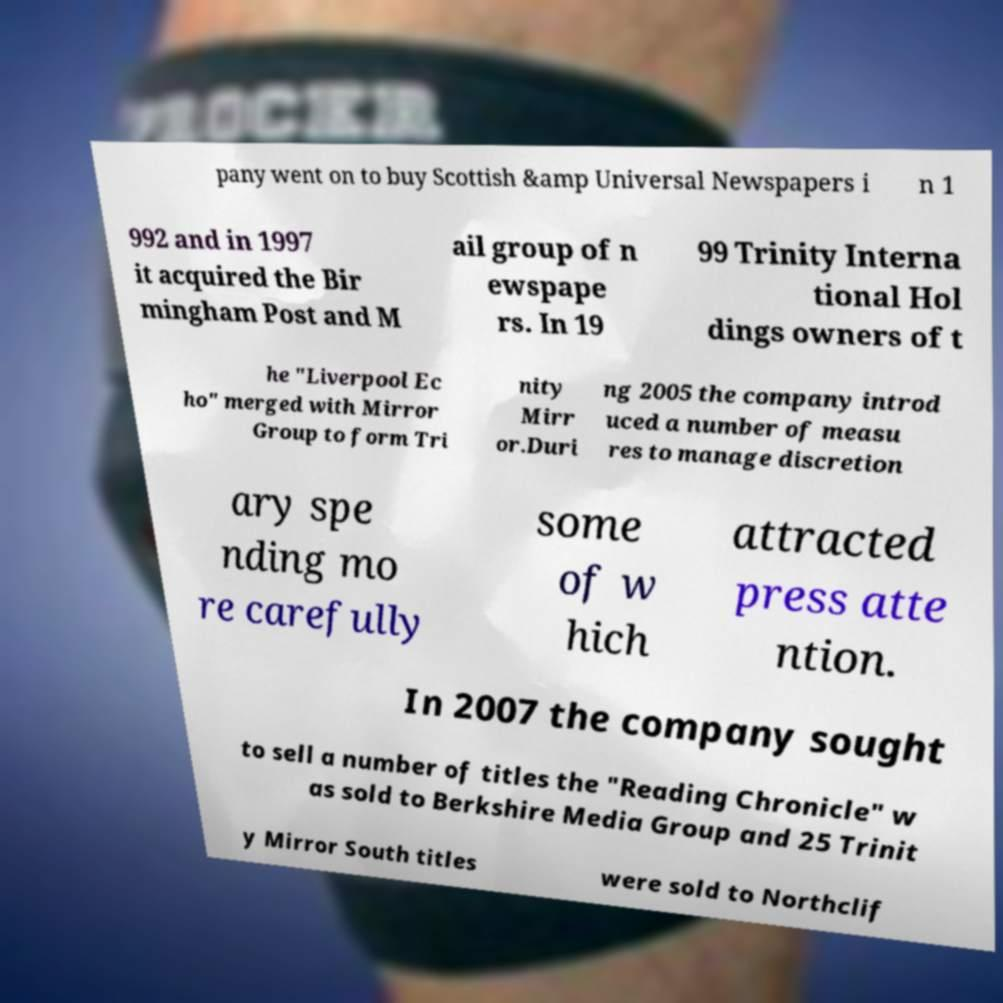For documentation purposes, I need the text within this image transcribed. Could you provide that? pany went on to buy Scottish &amp Universal Newspapers i n 1 992 and in 1997 it acquired the Bir mingham Post and M ail group of n ewspape rs. In 19 99 Trinity Interna tional Hol dings owners of t he "Liverpool Ec ho" merged with Mirror Group to form Tri nity Mirr or.Duri ng 2005 the company introd uced a number of measu res to manage discretion ary spe nding mo re carefully some of w hich attracted press atte ntion. In 2007 the company sought to sell a number of titles the "Reading Chronicle" w as sold to Berkshire Media Group and 25 Trinit y Mirror South titles were sold to Northclif 